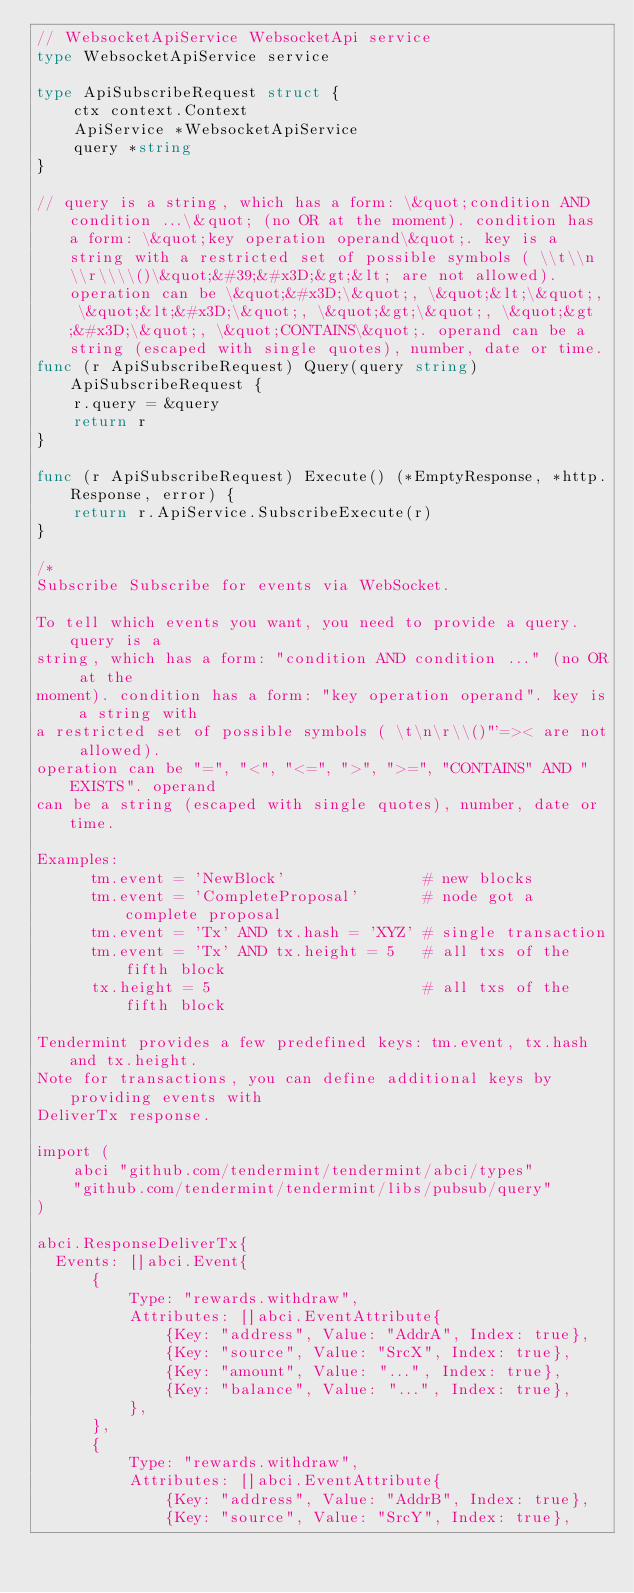Convert code to text. <code><loc_0><loc_0><loc_500><loc_500><_Go_>// WebsocketApiService WebsocketApi service
type WebsocketApiService service

type ApiSubscribeRequest struct {
	ctx context.Context
	ApiService *WebsocketApiService
	query *string
}

// query is a string, which has a form: \&quot;condition AND condition ...\&quot; (no OR at the moment). condition has a form: \&quot;key operation operand\&quot;. key is a string with a restricted set of possible symbols ( \\t\\n\\r\\\\()\&quot;&#39;&#x3D;&gt;&lt; are not allowed). operation can be \&quot;&#x3D;\&quot;, \&quot;&lt;\&quot;, \&quot;&lt;&#x3D;\&quot;, \&quot;&gt;\&quot;, \&quot;&gt;&#x3D;\&quot;, \&quot;CONTAINS\&quot;. operand can be a string (escaped with single quotes), number, date or time. 
func (r ApiSubscribeRequest) Query(query string) ApiSubscribeRequest {
	r.query = &query
	return r
}

func (r ApiSubscribeRequest) Execute() (*EmptyResponse, *http.Response, error) {
	return r.ApiService.SubscribeExecute(r)
}

/*
Subscribe Subscribe for events via WebSocket.

To tell which events you want, you need to provide a query. query is a
string, which has a form: "condition AND condition ..." (no OR at the
moment). condition has a form: "key operation operand". key is a string with
a restricted set of possible symbols ( \t\n\r\\()"'=>< are not allowed).
operation can be "=", "<", "<=", ">", ">=", "CONTAINS" AND "EXISTS". operand
can be a string (escaped with single quotes), number, date or time.

Examples:
      tm.event = 'NewBlock'               # new blocks
      tm.event = 'CompleteProposal'       # node got a complete proposal
      tm.event = 'Tx' AND tx.hash = 'XYZ' # single transaction
      tm.event = 'Tx' AND tx.height = 5   # all txs of the fifth block
      tx.height = 5                       # all txs of the fifth block

Tendermint provides a few predefined keys: tm.event, tx.hash and tx.height.
Note for transactions, you can define additional keys by providing events with
DeliverTx response.

import (
    abci "github.com/tendermint/tendermint/abci/types"
    "github.com/tendermint/tendermint/libs/pubsub/query"
)

abci.ResponseDeliverTx{
  Events: []abci.Event{
      {
          Type: "rewards.withdraw",
          Attributes: []abci.EventAttribute{
              {Key: "address", Value: "AddrA", Index: true},
              {Key: "source", Value: "SrcX", Index: true},
              {Key: "amount", Value: "...", Index: true},
              {Key: "balance", Value: "...", Index: true},
          },
      },
      {
          Type: "rewards.withdraw",
          Attributes: []abci.EventAttribute{
              {Key: "address", Value: "AddrB", Index: true},
              {Key: "source", Value: "SrcY", Index: true},</code> 